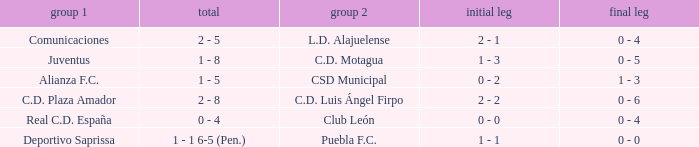What is the 1st leg where Team 1 is C.D. Plaza Amador? 2 - 2. 